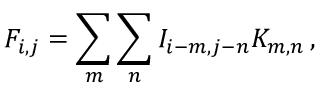<formula> <loc_0><loc_0><loc_500><loc_500>F _ { i , j } = \sum _ { m } \sum _ { n } I _ { i - m , j - n } K _ { m , n } \, ,</formula> 